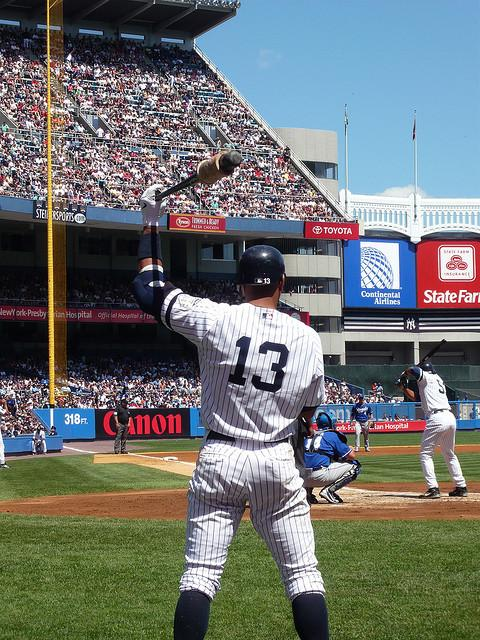What is the thing on the baseball bat for? Please explain your reasoning. warming up. It's thought to help increase speed after a. 